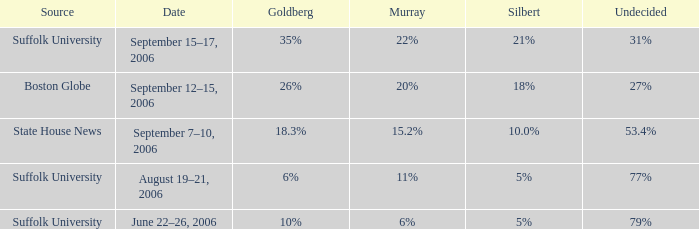What is the date of the poll with Silbert at 18%? September 12–15, 2006. 